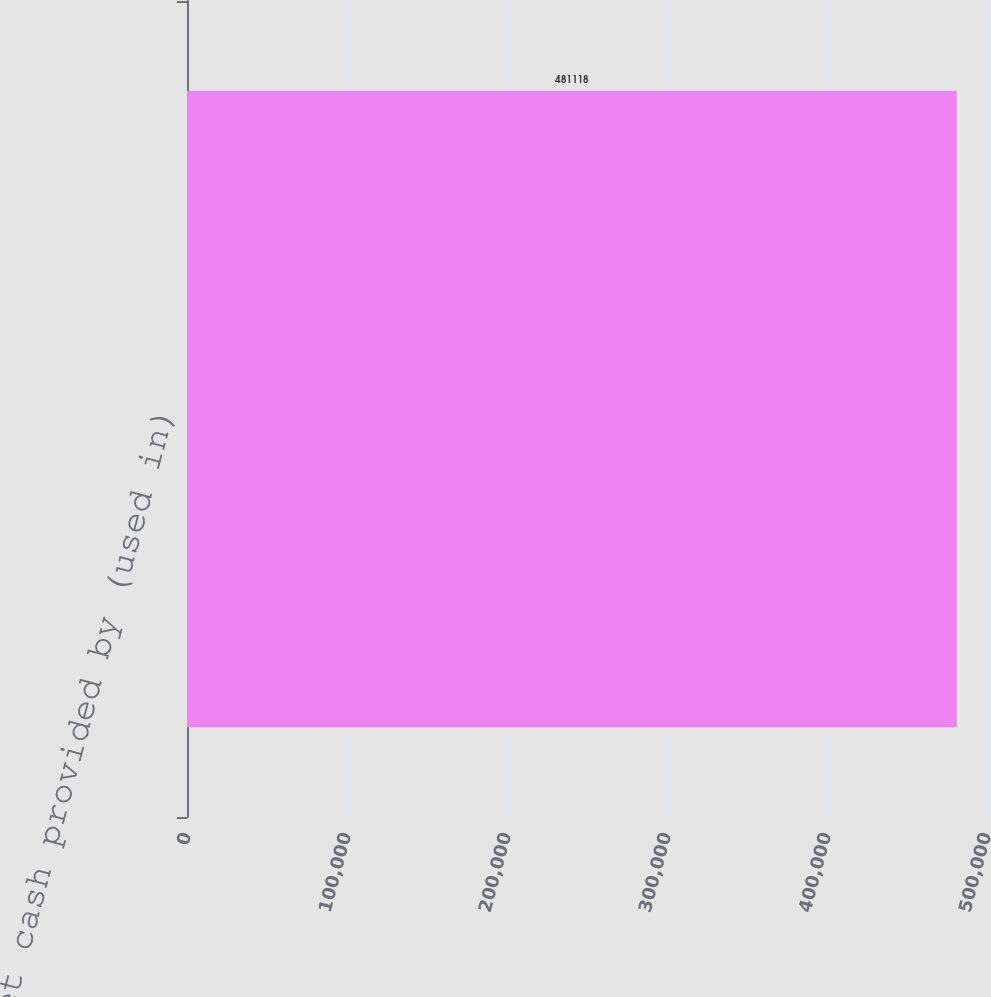<chart> <loc_0><loc_0><loc_500><loc_500><bar_chart><fcel>Net cash provided by (used in)<nl><fcel>481118<nl></chart> 